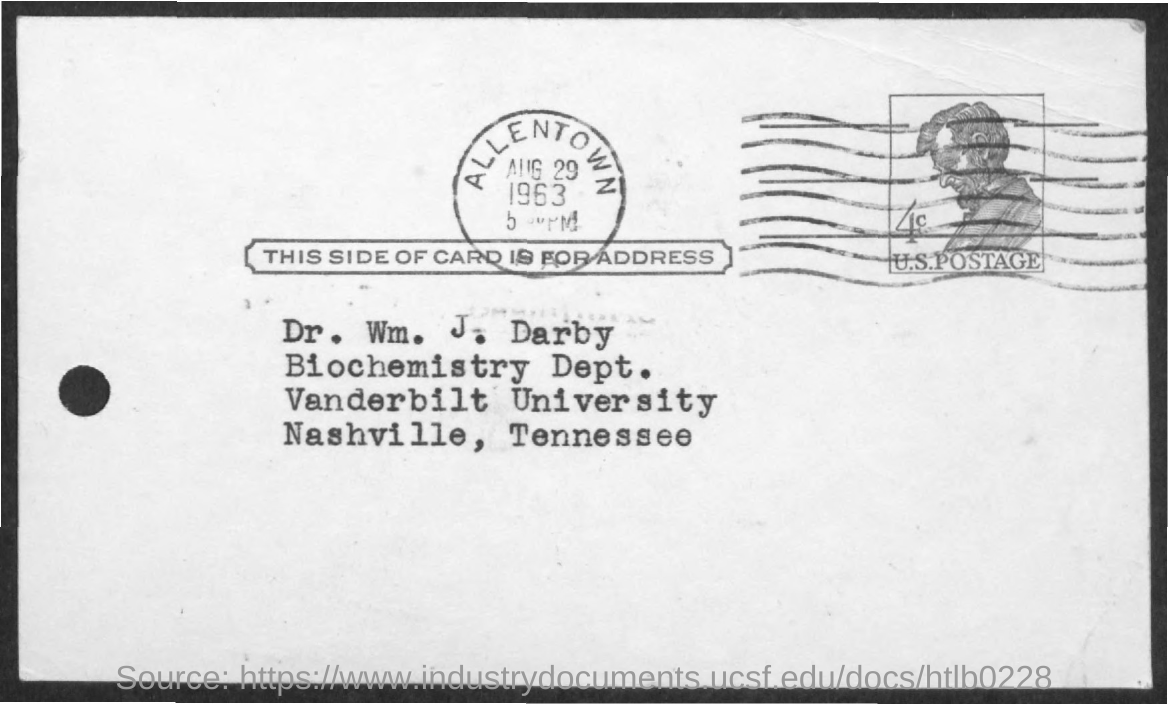What is the name of the person given in the address?
Provide a succinct answer. Dr. Wm. J. Darby. In which department does Dr. Wm. J. Darby belong to?
Give a very brief answer. Biochemistry Dept. What is the stamped date given in the postcard?
Make the answer very short. AUG 29 1963. 